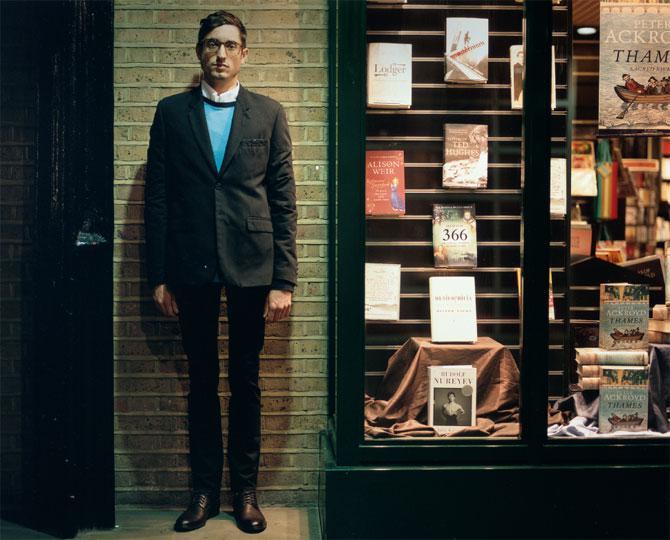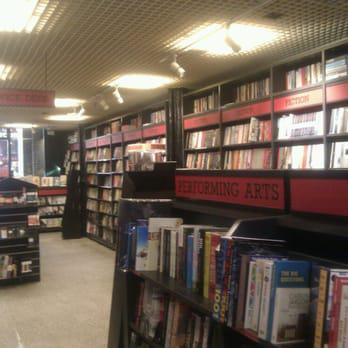The first image is the image on the left, the second image is the image on the right. Evaluate the accuracy of this statement regarding the images: "A large arch shape is in the center of the left image, surrounded by other window shapes.". Is it true? Answer yes or no. No. The first image is the image on the left, the second image is the image on the right. Evaluate the accuracy of this statement regarding the images: "There are people visible, walking right outside of the building.". Is it true? Answer yes or no. No. 